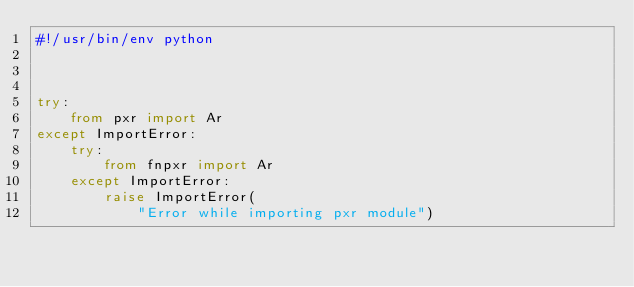Convert code to text. <code><loc_0><loc_0><loc_500><loc_500><_Python_>#!/usr/bin/env python



try:
    from pxr import Ar
except ImportError:
    try:
        from fnpxr import Ar
    except ImportError:
        raise ImportError(
            "Error while importing pxr module")
</code> 